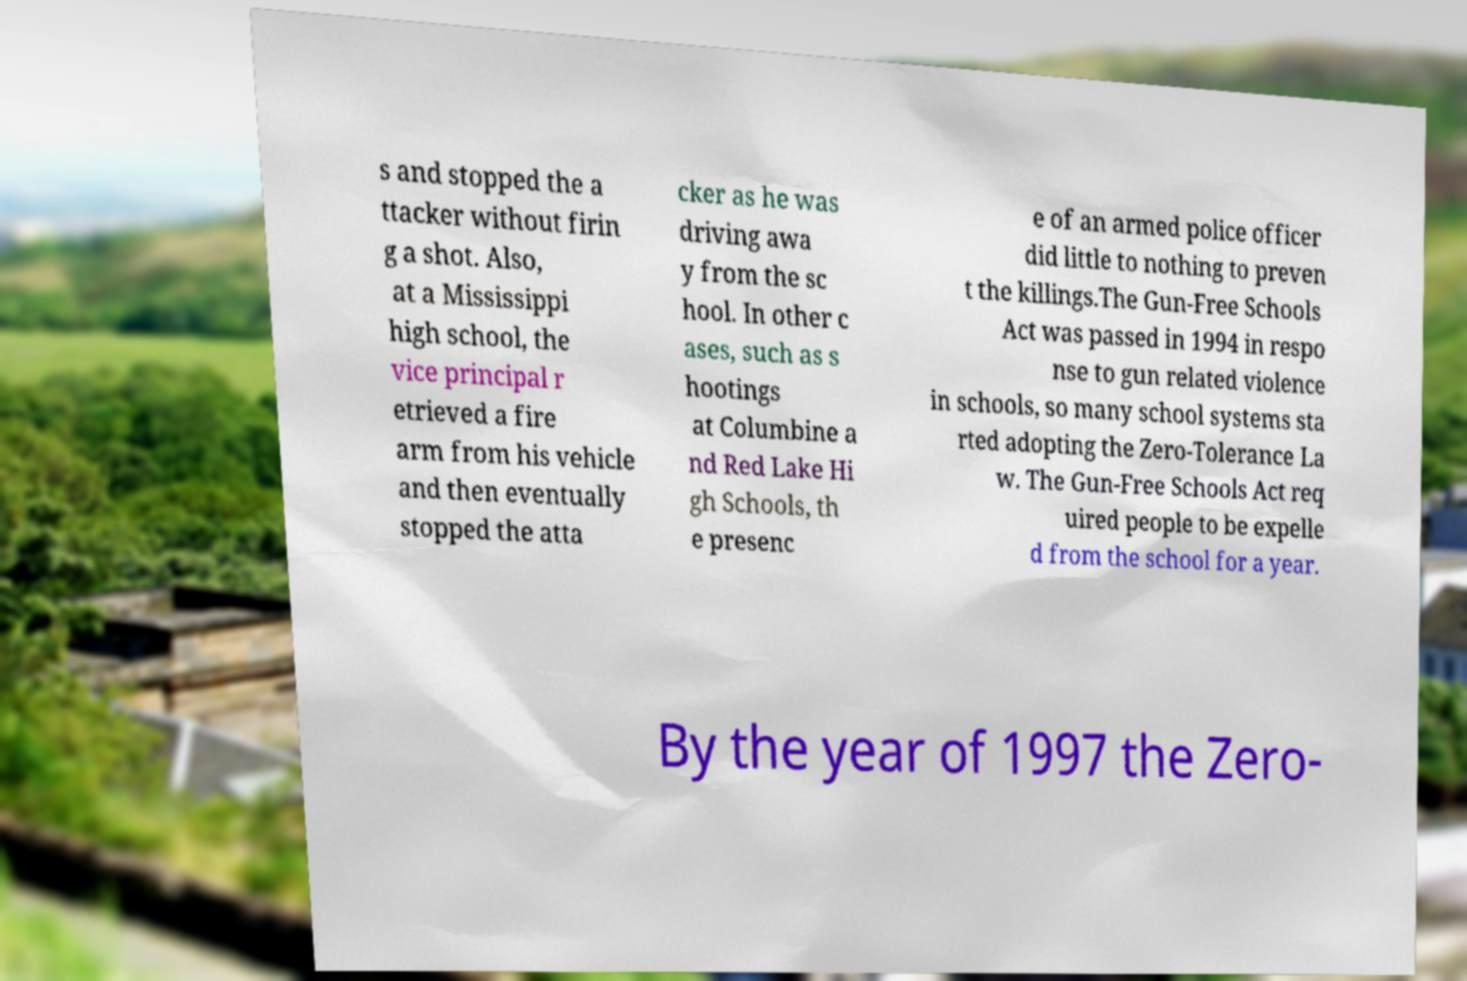There's text embedded in this image that I need extracted. Can you transcribe it verbatim? s and stopped the a ttacker without firin g a shot. Also, at a Mississippi high school, the vice principal r etrieved a fire arm from his vehicle and then eventually stopped the atta cker as he was driving awa y from the sc hool. In other c ases, such as s hootings at Columbine a nd Red Lake Hi gh Schools, th e presenc e of an armed police officer did little to nothing to preven t the killings.The Gun-Free Schools Act was passed in 1994 in respo nse to gun related violence in schools, so many school systems sta rted adopting the Zero-Tolerance La w. The Gun-Free Schools Act req uired people to be expelle d from the school for a year. By the year of 1997 the Zero- 